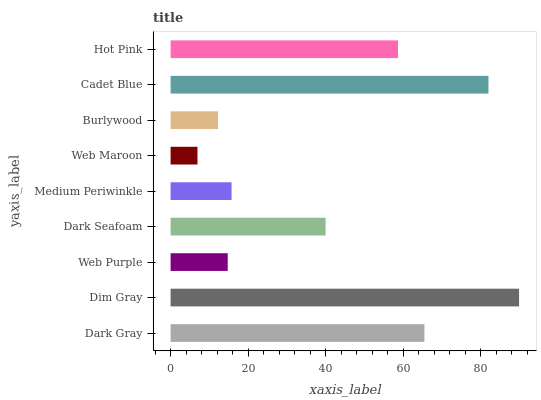Is Web Maroon the minimum?
Answer yes or no. Yes. Is Dim Gray the maximum?
Answer yes or no. Yes. Is Web Purple the minimum?
Answer yes or no. No. Is Web Purple the maximum?
Answer yes or no. No. Is Dim Gray greater than Web Purple?
Answer yes or no. Yes. Is Web Purple less than Dim Gray?
Answer yes or no. Yes. Is Web Purple greater than Dim Gray?
Answer yes or no. No. Is Dim Gray less than Web Purple?
Answer yes or no. No. Is Dark Seafoam the high median?
Answer yes or no. Yes. Is Dark Seafoam the low median?
Answer yes or no. Yes. Is Burlywood the high median?
Answer yes or no. No. Is Web Purple the low median?
Answer yes or no. No. 